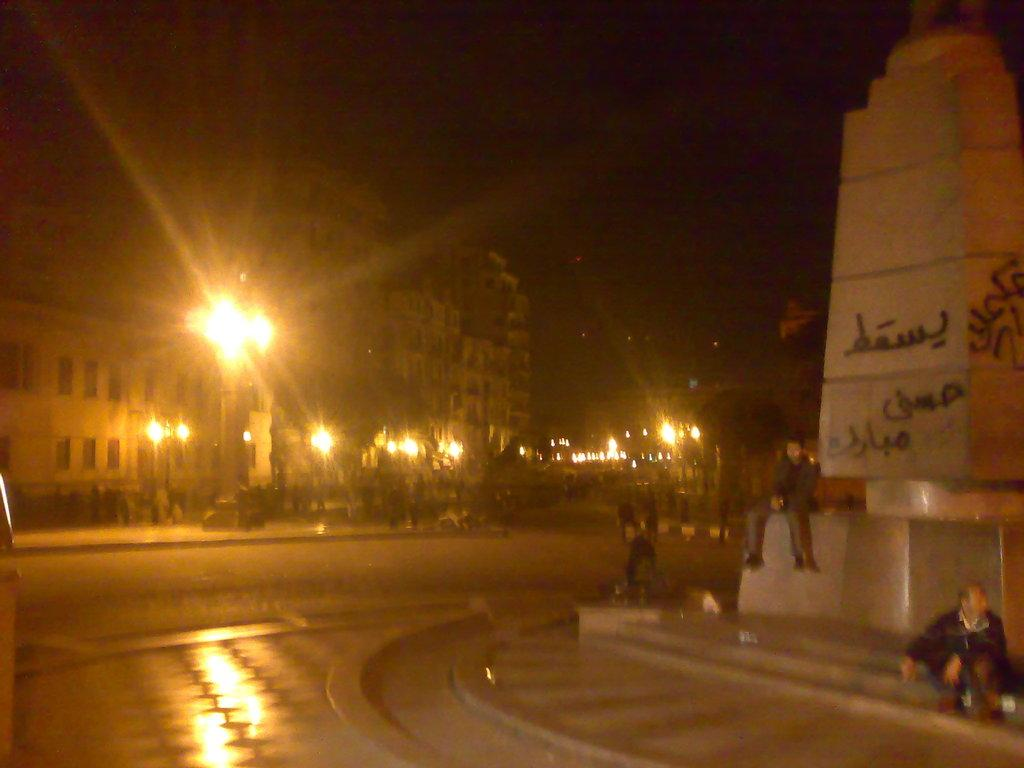What type of location is shown in the image? The image depicts a city. Can you describe the people in the image? There are groups of people in the image. What structures are present in the city? There are buildings in the image. What can be seen illuminating the city? There are lights in the image. What is visible in the background of the image? The sky is visible in the background of the image. Where is the kettle located in the image? There is no kettle present in the image. Can you describe the cobweb on the building in the image? There is no cobweb visible on any of the buildings in the image. 